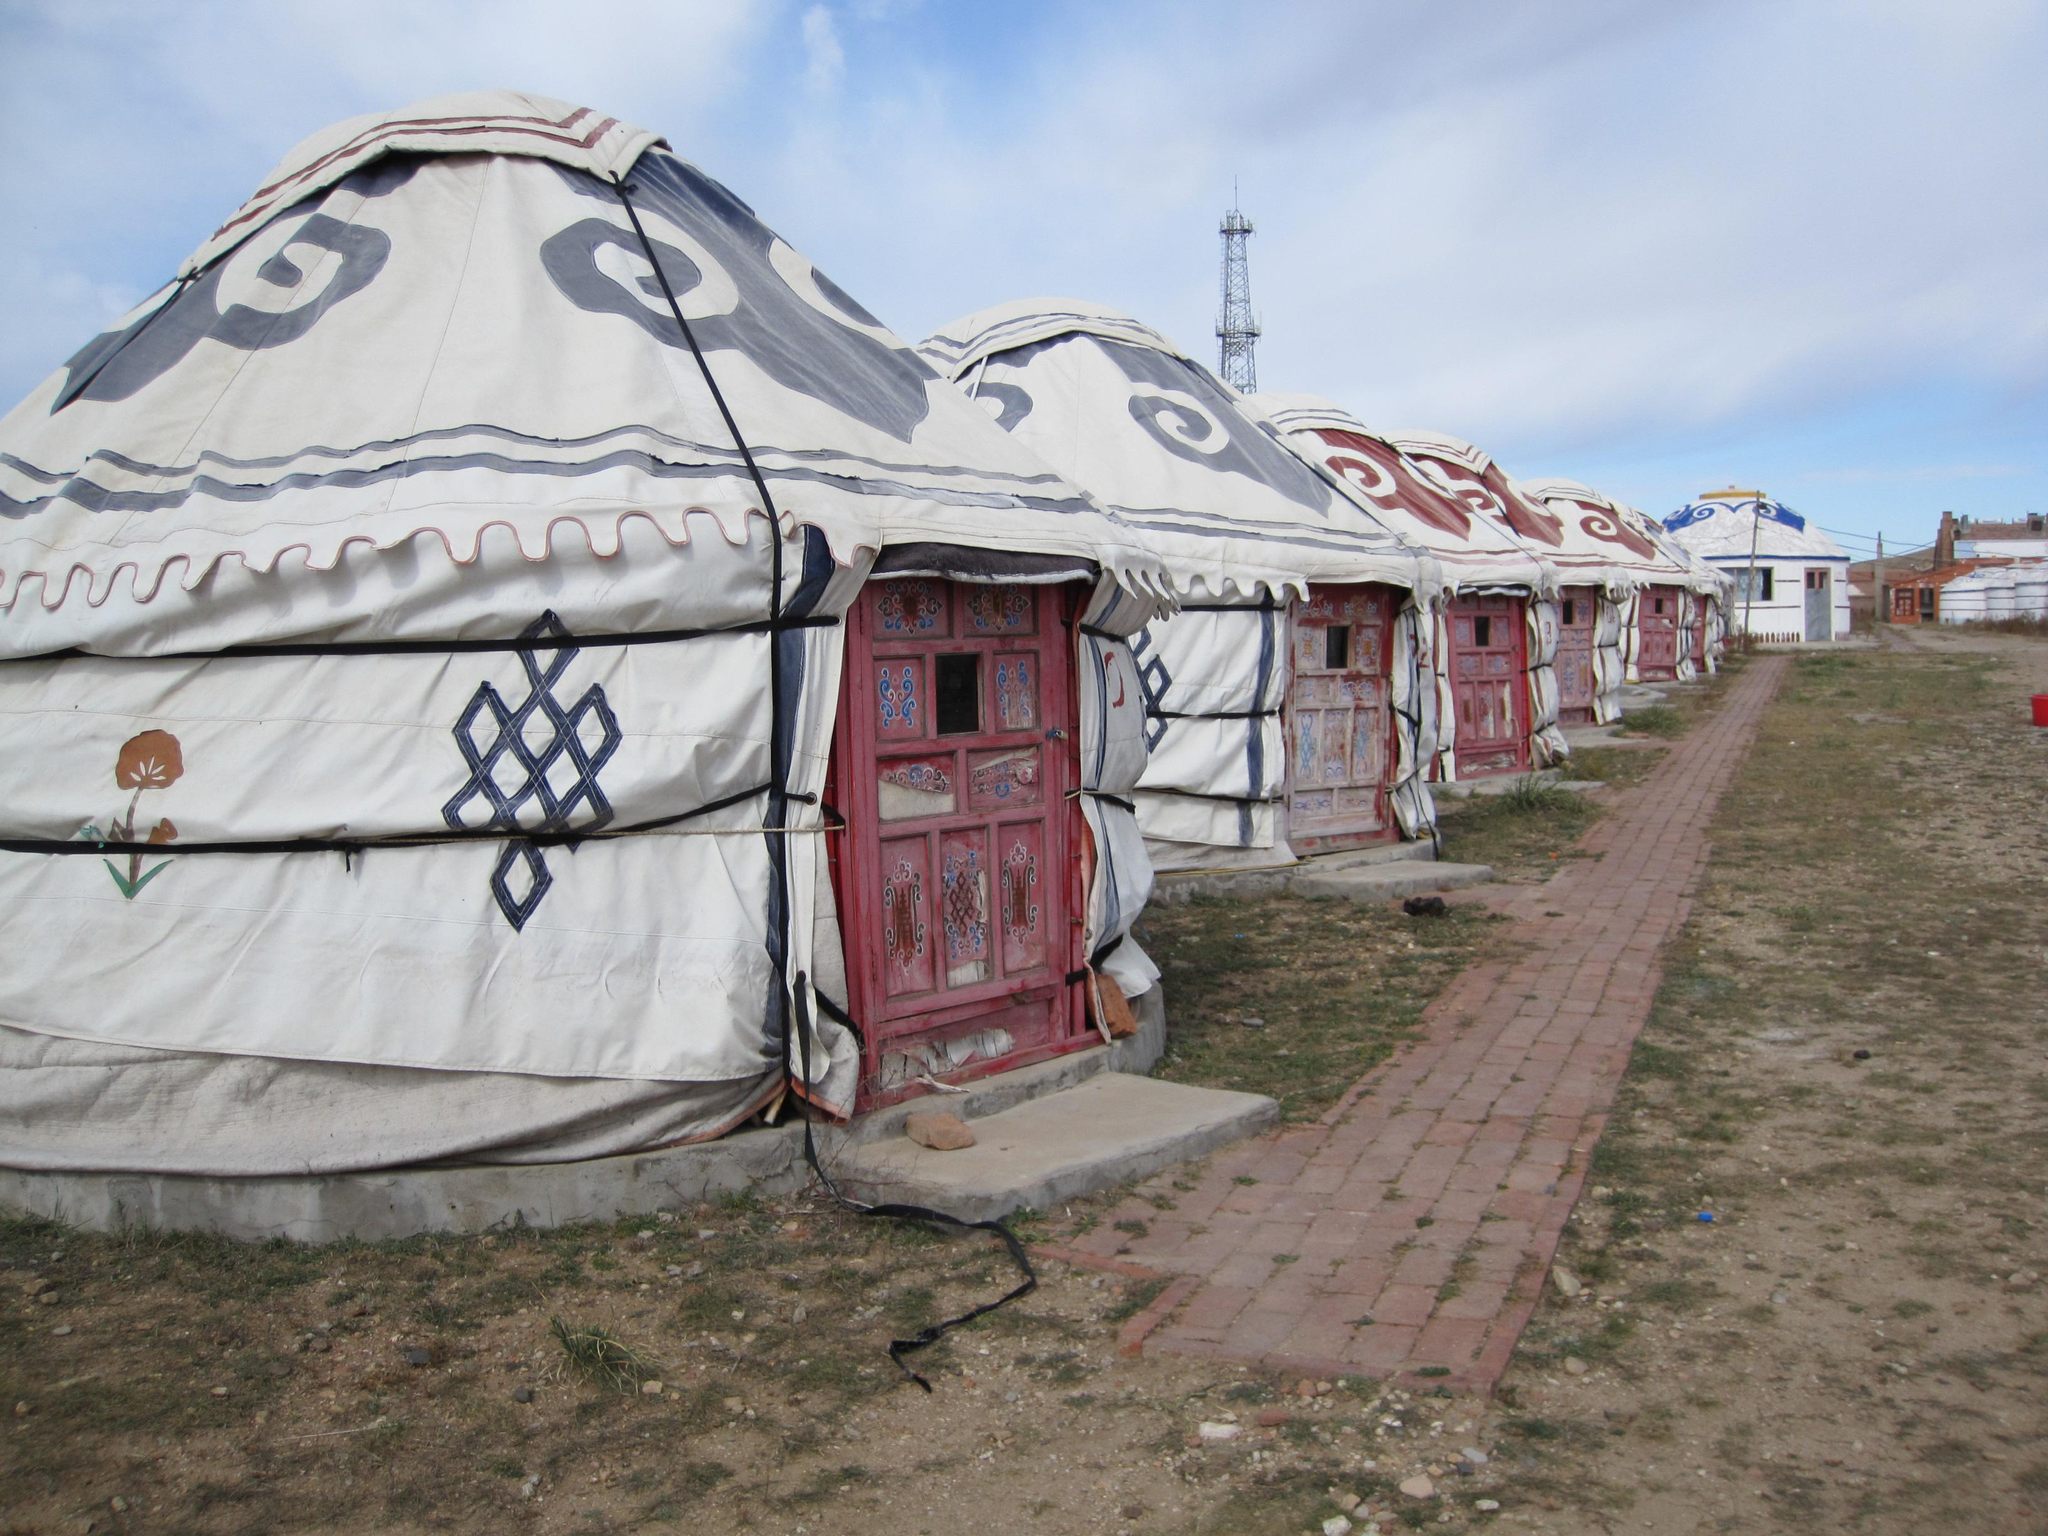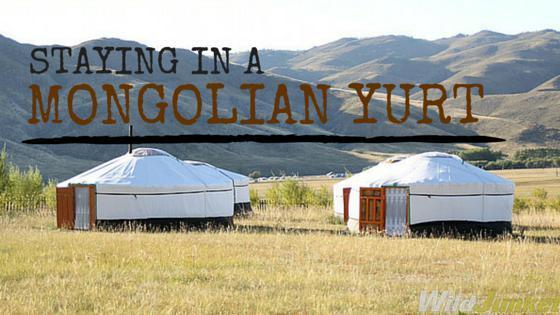The first image is the image on the left, the second image is the image on the right. Assess this claim about the two images: "At least one hut is not yet wrapped in fabric.". Correct or not? Answer yes or no. No. 